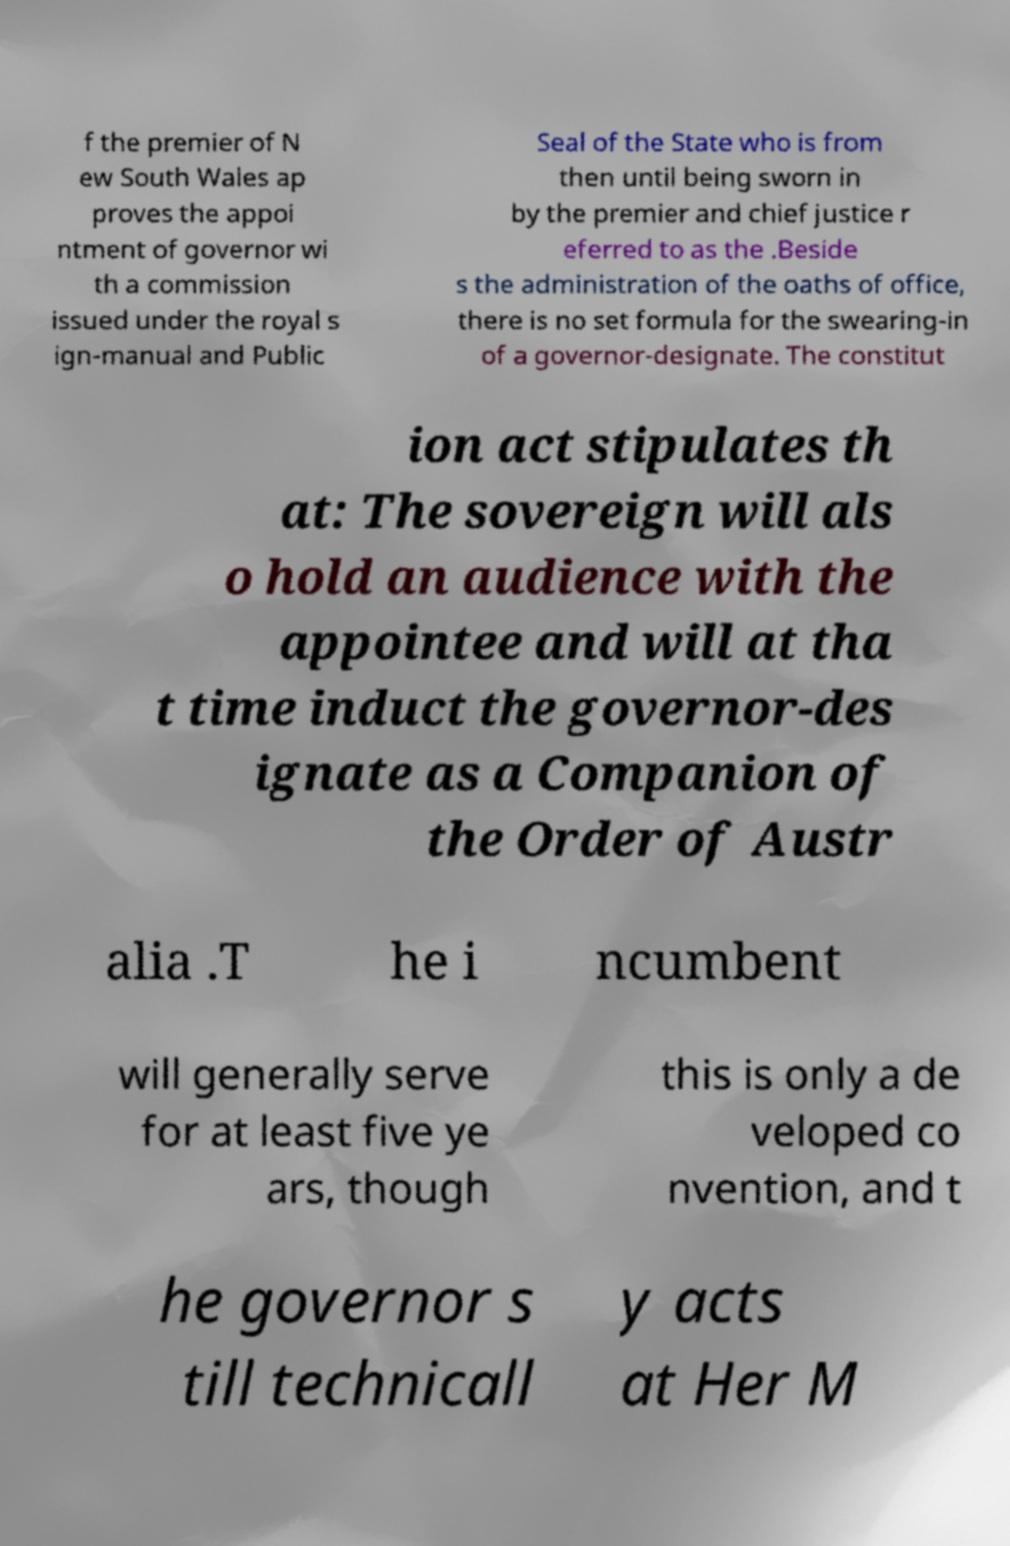Can you accurately transcribe the text from the provided image for me? f the premier of N ew South Wales ap proves the appoi ntment of governor wi th a commission issued under the royal s ign-manual and Public Seal of the State who is from then until being sworn in by the premier and chief justice r eferred to as the .Beside s the administration of the oaths of office, there is no set formula for the swearing-in of a governor-designate. The constitut ion act stipulates th at: The sovereign will als o hold an audience with the appointee and will at tha t time induct the governor-des ignate as a Companion of the Order of Austr alia .T he i ncumbent will generally serve for at least five ye ars, though this is only a de veloped co nvention, and t he governor s till technicall y acts at Her M 